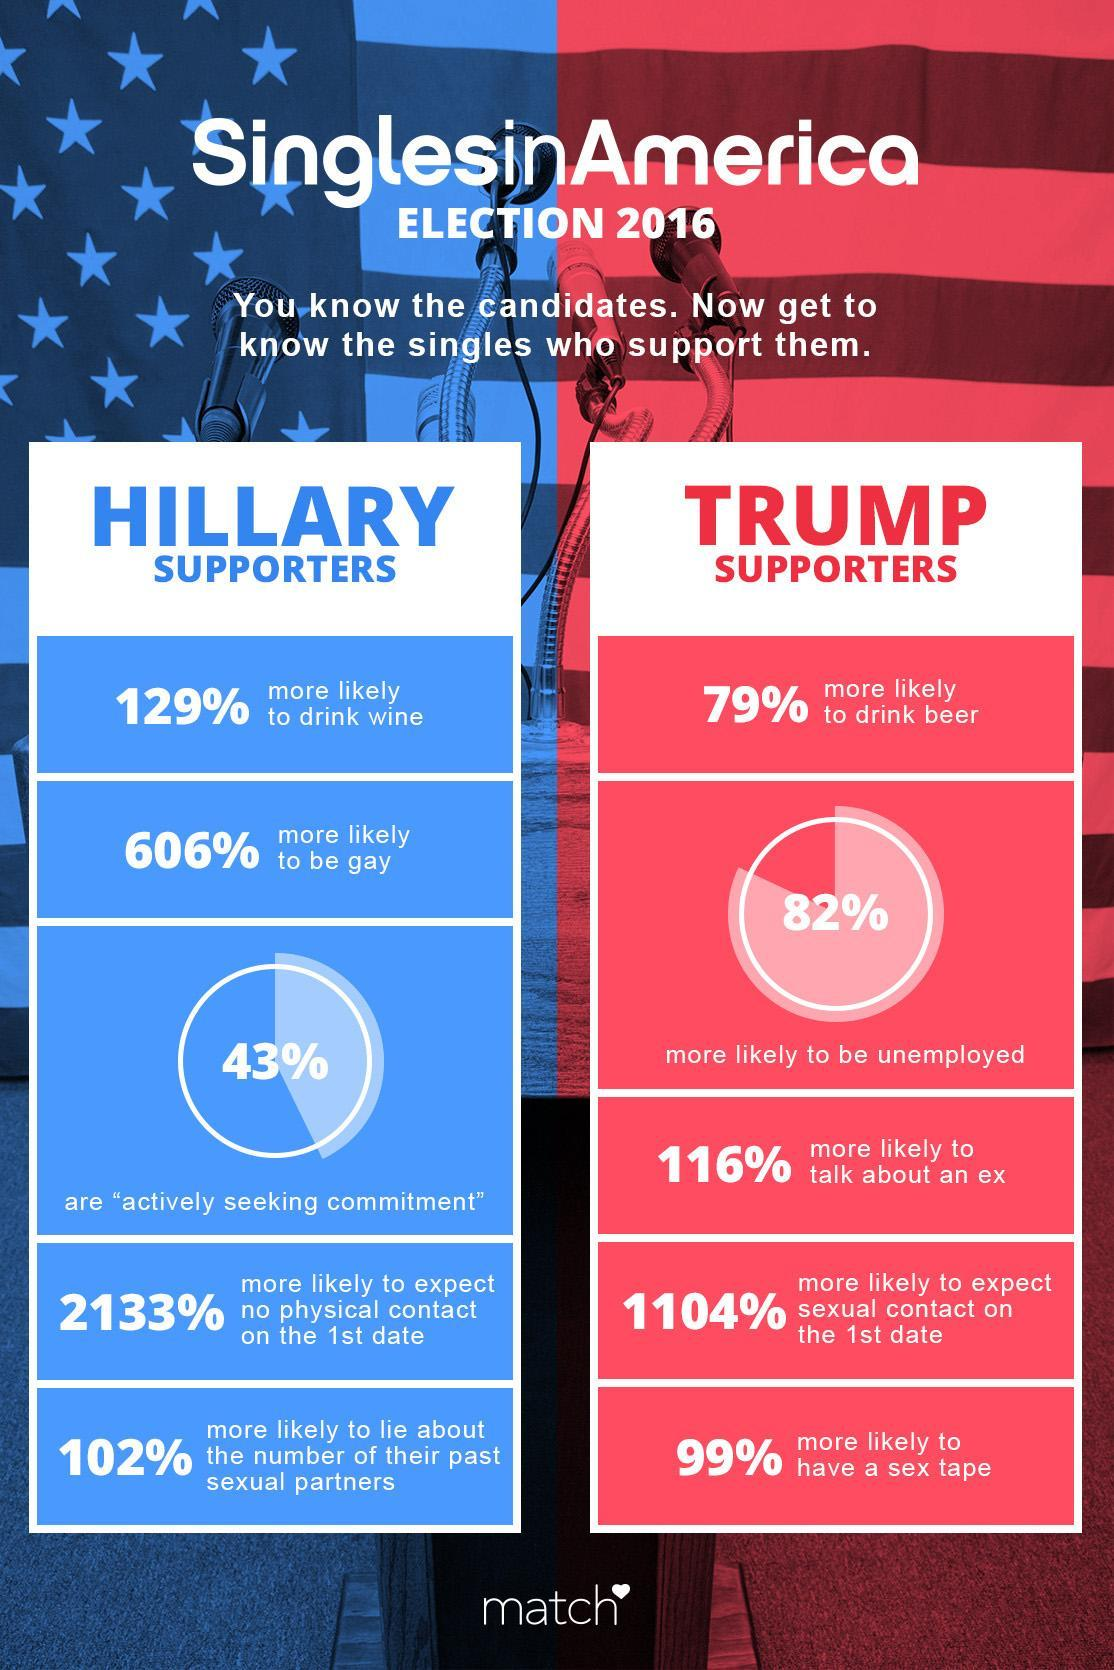What percent of the Trump supporters in 2016 Elections are more likely to have a sex tape?
Answer the question with a short phrase. 99% What percent of the Trump supporters in 2016 Elections are more likely to be unemployed? 82% What percent of the Hillary supporters in 2016 Elections are actively seeking commitment? 43% 